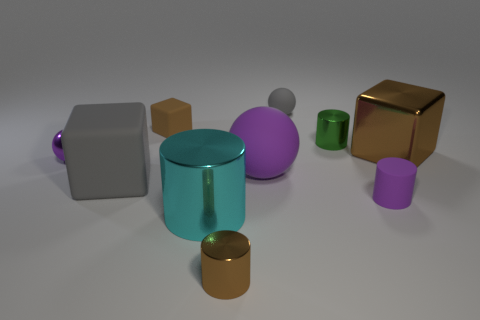Do the gray rubber block and the brown rubber object have the same size?
Keep it short and to the point. No. What shape is the purple object that is the same size as the gray block?
Provide a short and direct response. Sphere. How many things are either big things behind the rubber cylinder or metallic objects that are in front of the shiny sphere?
Provide a short and direct response. 5. What is the material of the block that is the same size as the gray ball?
Your answer should be compact. Rubber. Are there an equal number of big cyan cylinders on the right side of the small purple rubber cylinder and matte things that are in front of the small purple ball?
Your answer should be very brief. No. What number of purple things are small spheres or small rubber cylinders?
Make the answer very short. 2. Is the color of the large ball the same as the small ball that is to the left of the cyan cylinder?
Your response must be concise. Yes. How many other objects are there of the same color as the large metallic block?
Offer a terse response. 2. Is the number of purple cylinders less than the number of large brown cylinders?
Offer a very short reply. No. How many objects are right of the tiny metallic object on the right side of the small metallic cylinder left of the gray rubber ball?
Give a very brief answer. 2. 